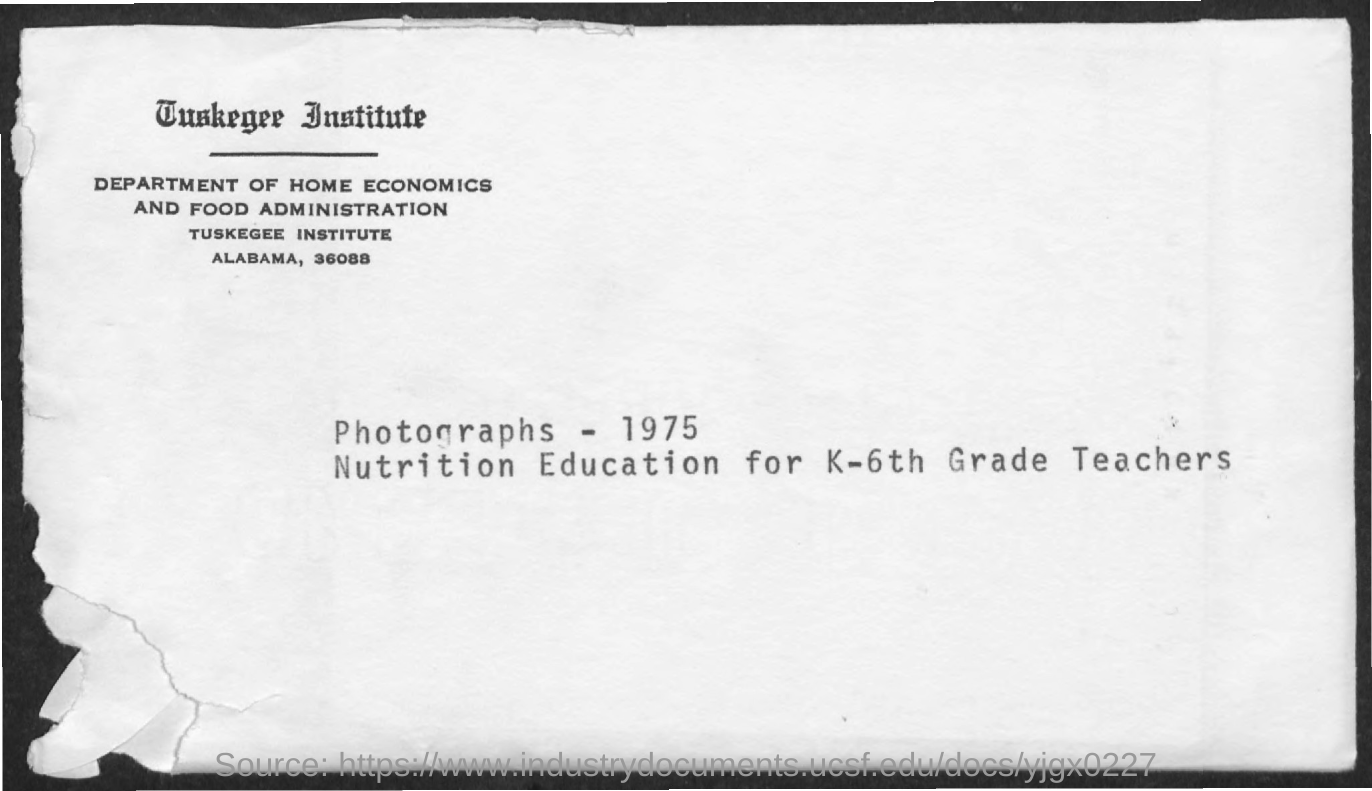What is the name of department?
Keep it short and to the point. DEPARTMENT OF HOME ECONOMICS AND FOOD ADMINISTRATION. How many photographs were mentioned?
Make the answer very short. 1975. 